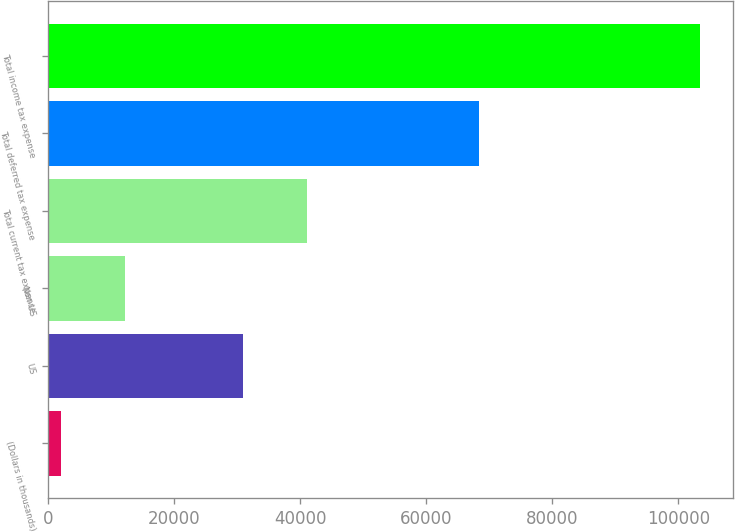<chart> <loc_0><loc_0><loc_500><loc_500><bar_chart><fcel>(Dollars in thousands)<fcel>US<fcel>Non-US<fcel>Total current tax expense<fcel>Total deferred tax expense<fcel>Total income tax expense<nl><fcel>2016<fcel>30971<fcel>12164.4<fcel>41119.4<fcel>68301<fcel>103500<nl></chart> 